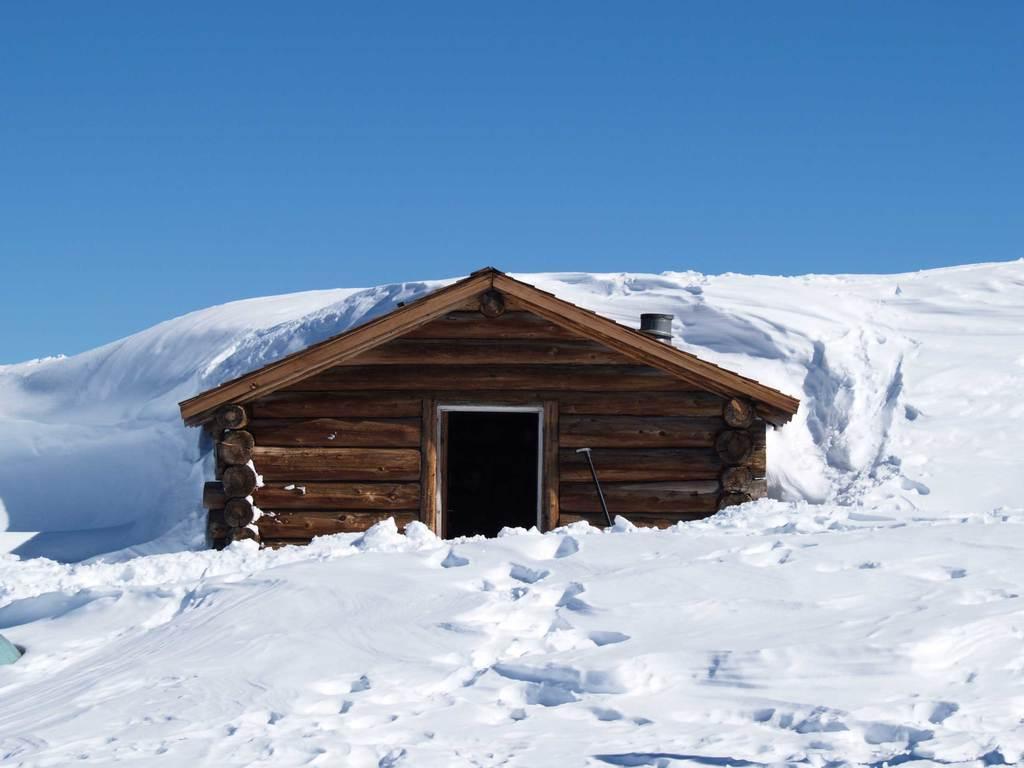Please provide a concise description of this image. In this image we can see snow. Also there is a wooden house. In the background there is sky. 